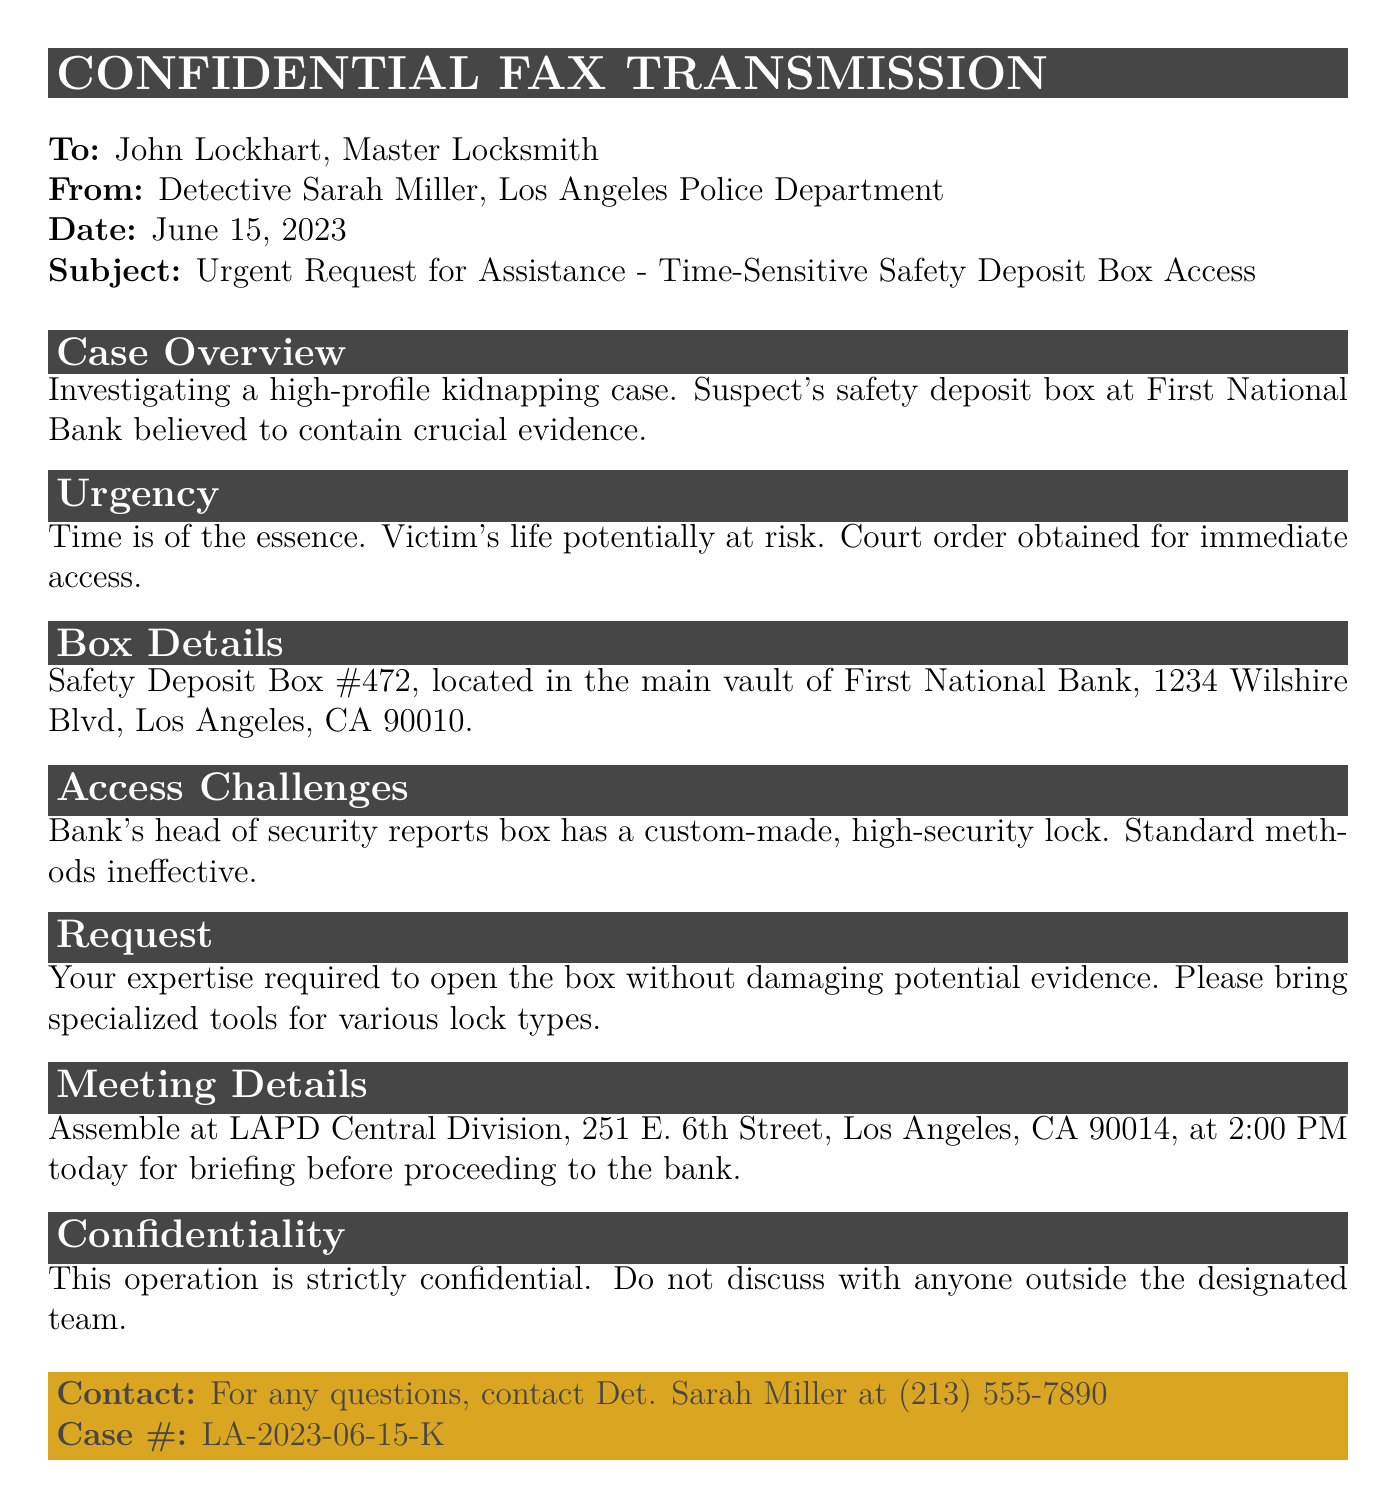What is the sender's name? The sender's name is stated in the document as Detective Sarah Miller from the Los Angeles Police Department.
Answer: Detective Sarah Miller What is the date of the fax? The date of the fax is provided in the document, specifically mentioning June 15, 2023.
Answer: June 15, 2023 What is the subject of the fax? The subject line clearly states it as an urgent request for assistance regarding accessing a time-sensitive safety deposit box.
Answer: Urgent Request for Assistance - Time-Sensitive Safety Deposit Box Access What is the location of the safety deposit box? The document specifies the location of the safety deposit box as First National Bank, 1234 Wilshire Blvd, Los Angeles, CA 90010.
Answer: First National Bank, 1234 Wilshire Blvd, Los Angeles, CA 90010 What is the urgency stated in the document? The urgency is highlighted as time-sensitive due to the potential risk to the victim's life and a court order for immediate access.
Answer: Time-sensitive What is the box number mentioned in the fax? The box number provided in the document is Safety Deposit Box #472.
Answer: Safety Deposit Box #472 What time is the meeting scheduled for? The document indicates that the meeting is scheduled for 2:00 PM today.
Answer: 2:00 PM What does the document state about confidentiality? It states that the operation is strictly confidential and should not be discussed outside the designated team.
Answer: Strictly confidential What is requested from the locksmith regarding tools? The document requests the locksmith to bring specialized tools for various lock types.
Answer: Specialized tools for various lock types 